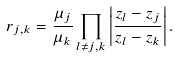<formula> <loc_0><loc_0><loc_500><loc_500>r _ { j , k } = \frac { \mu _ { j } } { \mu _ { k } } \prod _ { l \neq j , k } \left | \frac { z _ { l } - z _ { j } } { z _ { l } - z _ { k } } \right | .</formula> 